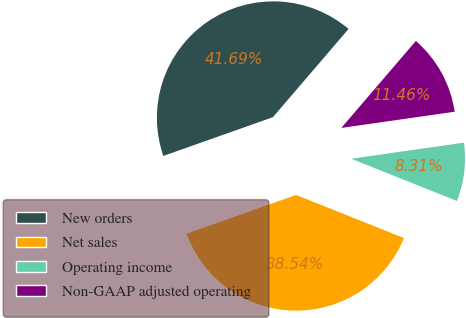Convert chart to OTSL. <chart><loc_0><loc_0><loc_500><loc_500><pie_chart><fcel>New orders<fcel>Net sales<fcel>Operating income<fcel>Non-GAAP adjusted operating<nl><fcel>41.69%<fcel>38.54%<fcel>8.31%<fcel>11.46%<nl></chart> 